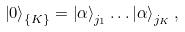<formula> <loc_0><loc_0><loc_500><loc_500>\left | 0 \right \rangle _ { \{ K \} } = \left | \alpha \right \rangle _ { j _ { 1 } } \dots \left | \alpha \right \rangle _ { j _ { K } } ,</formula> 